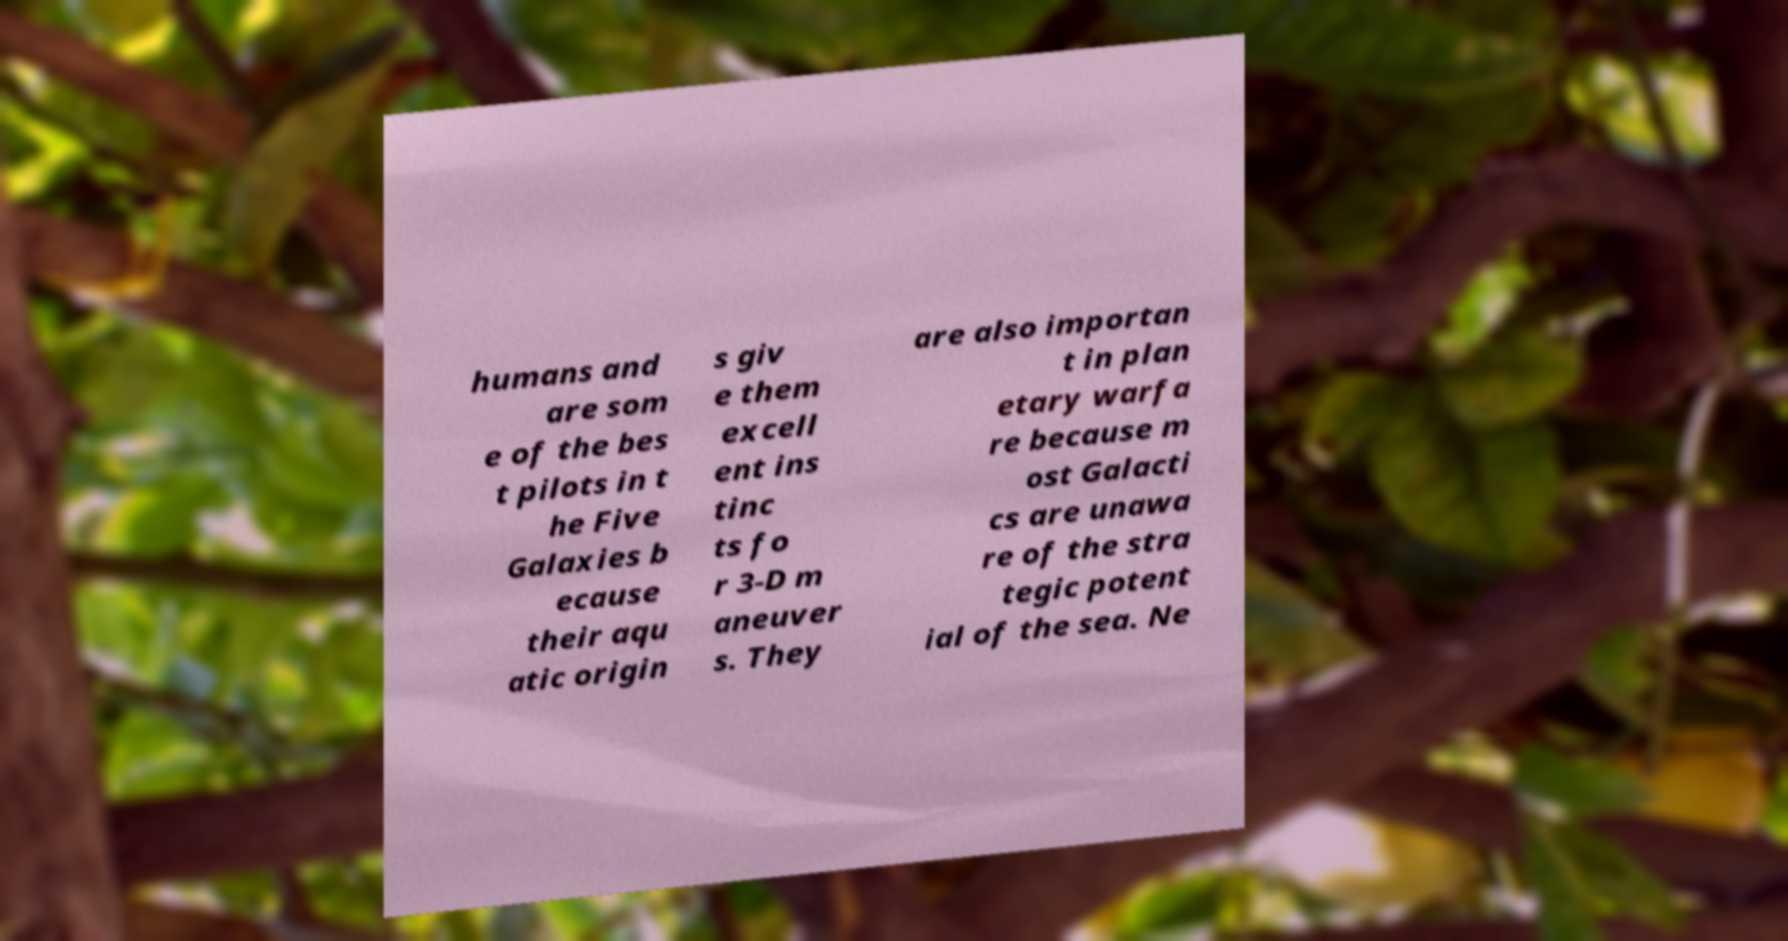What messages or text are displayed in this image? I need them in a readable, typed format. humans and are som e of the bes t pilots in t he Five Galaxies b ecause their aqu atic origin s giv e them excell ent ins tinc ts fo r 3-D m aneuver s. They are also importan t in plan etary warfa re because m ost Galacti cs are unawa re of the stra tegic potent ial of the sea. Ne 